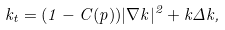Convert formula to latex. <formula><loc_0><loc_0><loc_500><loc_500>k _ { t } = ( 1 - C ( p ) ) | \nabla k | ^ { 2 } + k \Delta k ,</formula> 